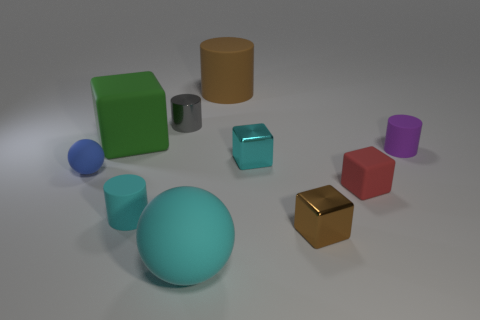Subtract all small red rubber blocks. How many blocks are left? 3 Subtract all red cubes. How many cubes are left? 3 Subtract all balls. How many objects are left? 8 Subtract all cyan blocks. Subtract all blue balls. How many blocks are left? 3 Subtract all brown rubber things. Subtract all blue objects. How many objects are left? 8 Add 8 cyan balls. How many cyan balls are left? 9 Add 3 purple cylinders. How many purple cylinders exist? 4 Subtract 1 blue balls. How many objects are left? 9 